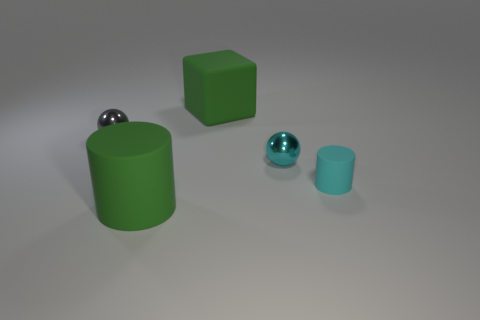What number of green rubber things are the same shape as the small cyan matte thing?
Make the answer very short. 1. There is a green block that is made of the same material as the green cylinder; what is its size?
Offer a terse response. Large. Are there an equal number of matte objects that are on the left side of the gray object and small green things?
Make the answer very short. Yes. Does the large matte cylinder have the same color as the large block?
Provide a short and direct response. Yes. Do the rubber object that is behind the small gray metal thing and the green matte thing that is in front of the gray metal sphere have the same shape?
Your response must be concise. No. What is the material of the big green object that is the same shape as the cyan rubber thing?
Make the answer very short. Rubber. What color is the object that is on the left side of the block and in front of the tiny cyan metallic sphere?
Your answer should be very brief. Green. There is a cyan metal object that is left of the cyan cylinder in front of the cyan sphere; is there a big green thing behind it?
Provide a succinct answer. Yes. What number of things are either gray metal things or green blocks?
Offer a terse response. 2. Do the tiny gray thing and the tiny ball that is in front of the small gray metallic ball have the same material?
Give a very brief answer. Yes. 